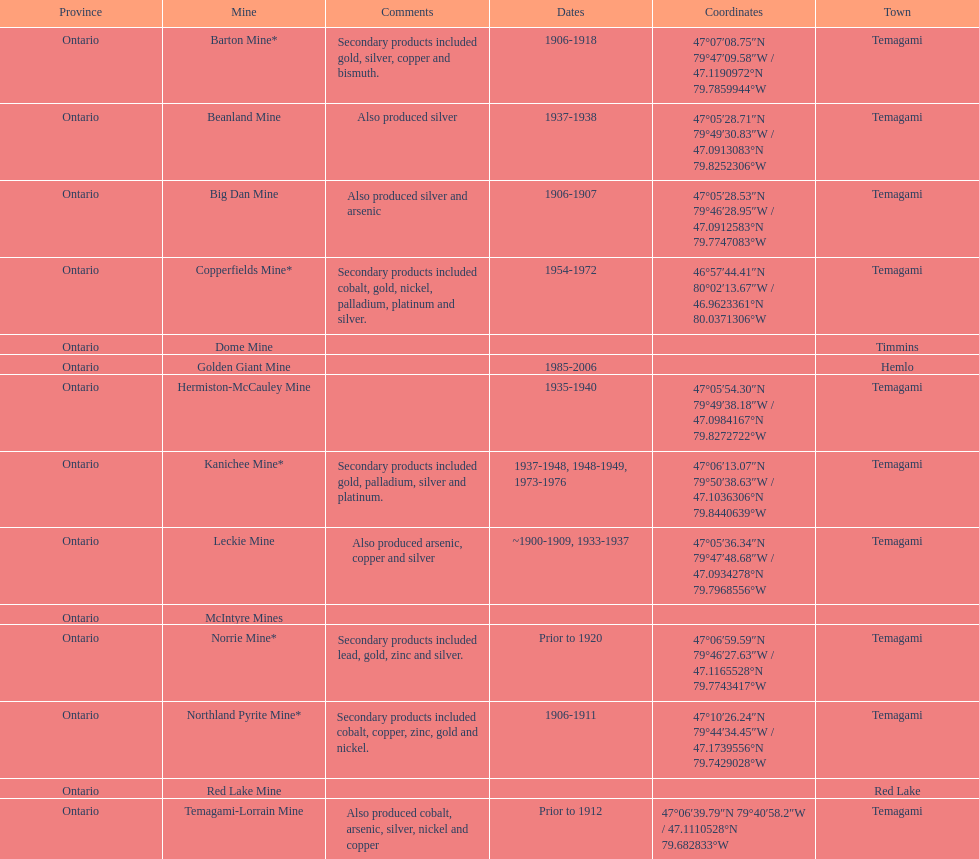How many mines were in temagami? 10. 